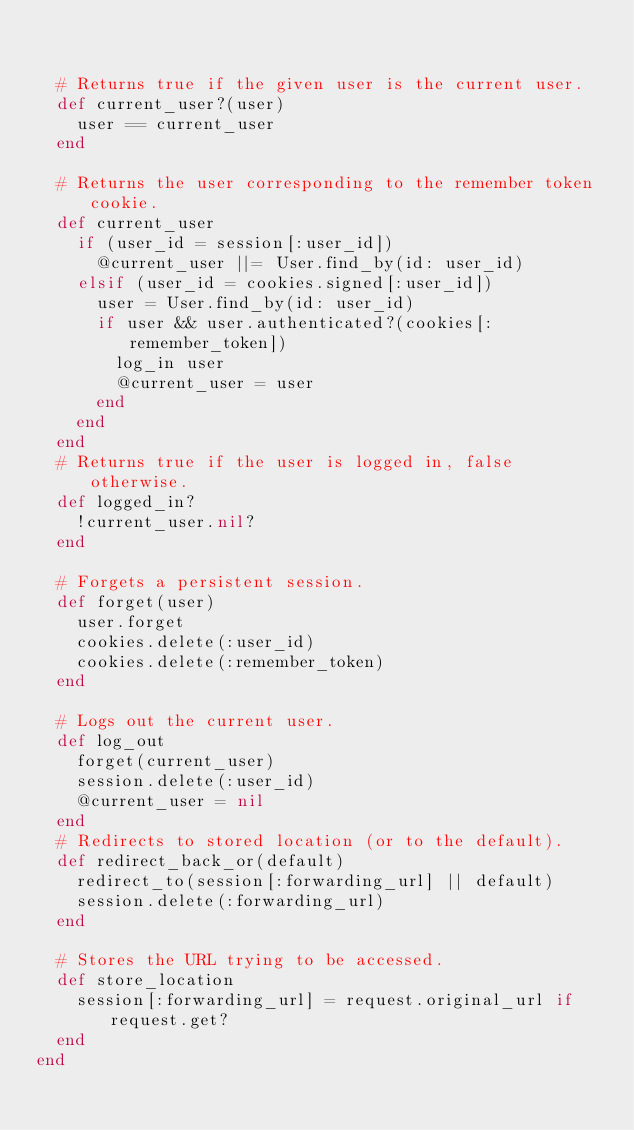Convert code to text. <code><loc_0><loc_0><loc_500><loc_500><_Ruby_>

  # Returns true if the given user is the current user.
  def current_user?(user)
    user == current_user
  end
  
  # Returns the user corresponding to the remember token cookie.
  def current_user
    if (user_id = session[:user_id])
      @current_user ||= User.find_by(id: user_id)
    elsif (user_id = cookies.signed[:user_id])
      user = User.find_by(id: user_id)
      if user && user.authenticated?(cookies[:remember_token])
        log_in user
        @current_user = user
      end
    end
  end
  # Returns true if the user is logged in, false otherwise.
  def logged_in?
    !current_user.nil?
  end

  # Forgets a persistent session.
  def forget(user)
    user.forget
    cookies.delete(:user_id)
    cookies.delete(:remember_token)
  end

  # Logs out the current user.
  def log_out
    forget(current_user)
    session.delete(:user_id)
    @current_user = nil
  end
  # Redirects to stored location (or to the default).
  def redirect_back_or(default)
    redirect_to(session[:forwarding_url] || default)
    session.delete(:forwarding_url)
  end

  # Stores the URL trying to be accessed.
  def store_location
    session[:forwarding_url] = request.original_url if request.get?
  end
end</code> 